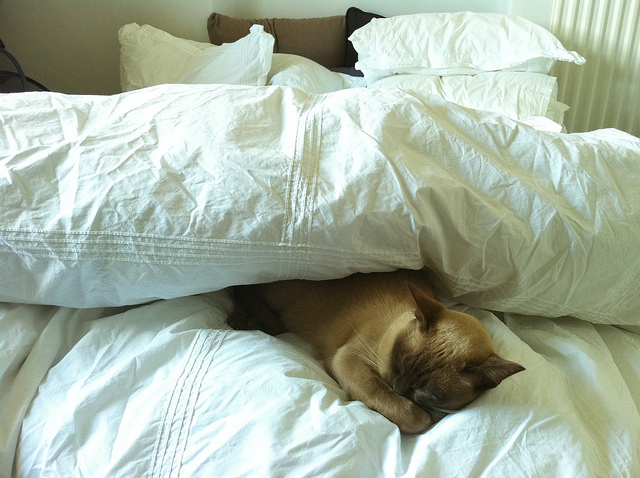<image>What pattern is on the cat's tail? I don't know what pattern is on the cat's tail. It could be solid color, stripes or rings. What pattern is on the cat's tail? I don't know what pattern is on the cat's tail. It can be either solid color, stripe, or solid dark color. 